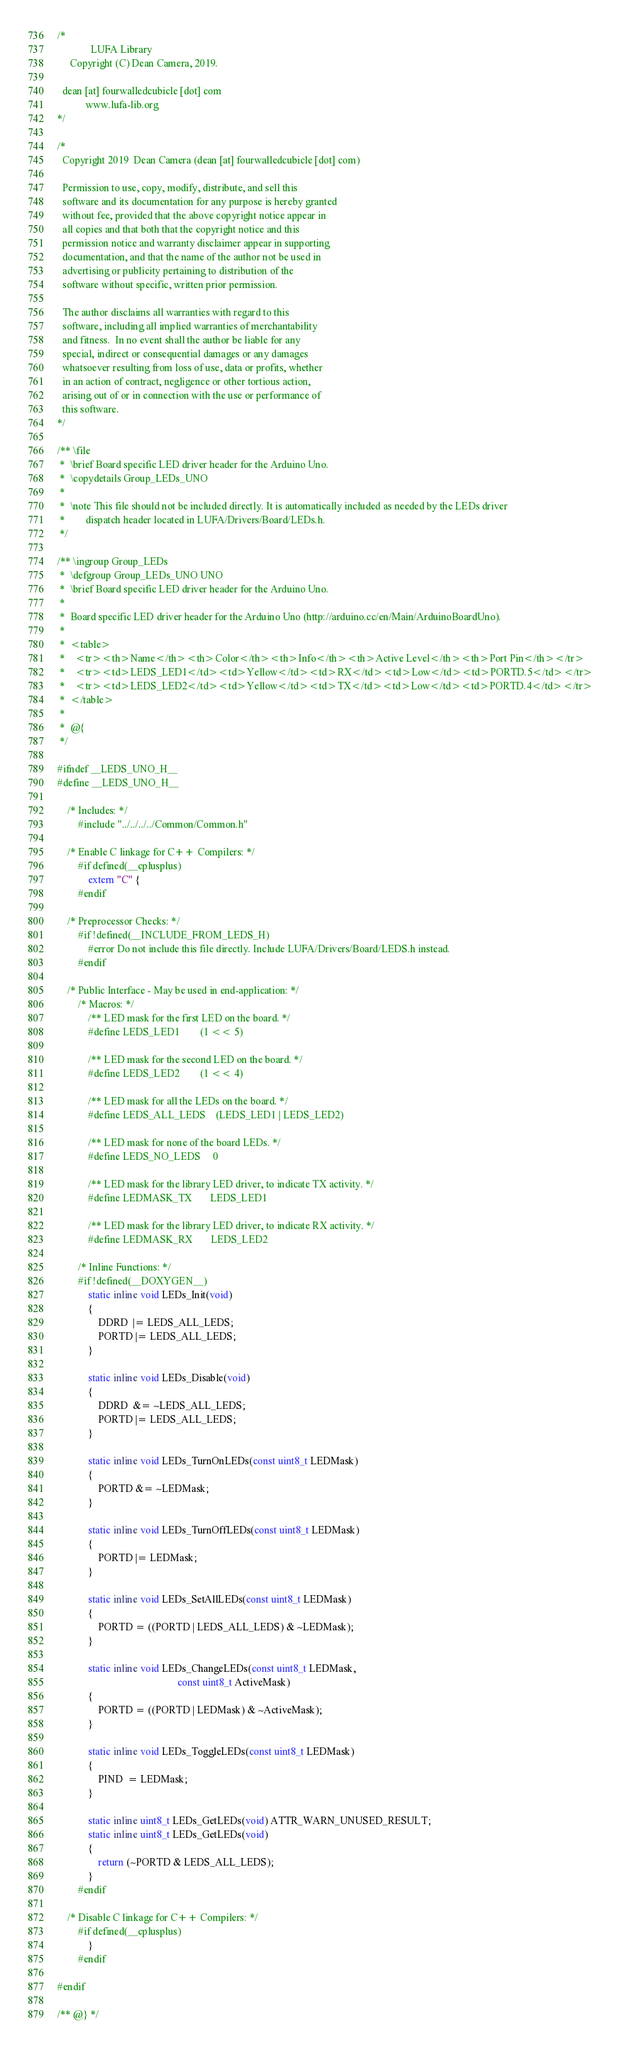Convert code to text. <code><loc_0><loc_0><loc_500><loc_500><_C_>/*
             LUFA Library
     Copyright (C) Dean Camera, 2019.

  dean [at] fourwalledcubicle [dot] com
           www.lufa-lib.org
*/

/*
  Copyright 2019  Dean Camera (dean [at] fourwalledcubicle [dot] com)

  Permission to use, copy, modify, distribute, and sell this
  software and its documentation for any purpose is hereby granted
  without fee, provided that the above copyright notice appear in
  all copies and that both that the copyright notice and this
  permission notice and warranty disclaimer appear in supporting
  documentation, and that the name of the author not be used in
  advertising or publicity pertaining to distribution of the
  software without specific, written prior permission.

  The author disclaims all warranties with regard to this
  software, including all implied warranties of merchantability
  and fitness.  In no event shall the author be liable for any
  special, indirect or consequential damages or any damages
  whatsoever resulting from loss of use, data or profits, whether
  in an action of contract, negligence or other tortious action,
  arising out of or in connection with the use or performance of
  this software.
*/

/** \file
 *  \brief Board specific LED driver header for the Arduino Uno.
 *  \copydetails Group_LEDs_UNO
 *
 *  \note This file should not be included directly. It is automatically included as needed by the LEDs driver
 *        dispatch header located in LUFA/Drivers/Board/LEDs.h.
 */

/** \ingroup Group_LEDs
 *  \defgroup Group_LEDs_UNO UNO
 *  \brief Board specific LED driver header for the Arduino Uno.
 *
 *  Board specific LED driver header for the Arduino Uno (http://arduino.cc/en/Main/ArduinoBoardUno).
 *
 *  <table>
 *    <tr><th>Name</th><th>Color</th><th>Info</th><th>Active Level</th><th>Port Pin</th></tr>
 *    <tr><td>LEDS_LED1</td><td>Yellow</td><td>RX</td><td>Low</td><td>PORTD.5</td></tr>
 *    <tr><td>LEDS_LED2</td><td>Yellow</td><td>TX</td><td>Low</td><td>PORTD.4</td></tr>
 *  </table>
 *
 *  @{
 */

#ifndef __LEDS_UNO_H__
#define __LEDS_UNO_H__

	/* Includes: */
		#include "../../../../Common/Common.h"

	/* Enable C linkage for C++ Compilers: */
		#if defined(__cplusplus)
			extern "C" {
		#endif

	/* Preprocessor Checks: */
		#if !defined(__INCLUDE_FROM_LEDS_H)
			#error Do not include this file directly. Include LUFA/Drivers/Board/LEDS.h instead.
		#endif

	/* Public Interface - May be used in end-application: */
		/* Macros: */
			/** LED mask for the first LED on the board. */
			#define LEDS_LED1        (1 << 5)

			/** LED mask for the second LED on the board. */
			#define LEDS_LED2        (1 << 4)

			/** LED mask for all the LEDs on the board. */
			#define LEDS_ALL_LEDS    (LEDS_LED1 | LEDS_LED2)

			/** LED mask for none of the board LEDs. */
			#define LEDS_NO_LEDS     0

			/** LED mask for the library LED driver, to indicate TX activity. */
			#define LEDMASK_TX       LEDS_LED1

			/** LED mask for the library LED driver, to indicate RX activity. */
			#define LEDMASK_RX       LEDS_LED2

		/* Inline Functions: */
		#if !defined(__DOXYGEN__)
			static inline void LEDs_Init(void)
			{
				DDRD  |= LEDS_ALL_LEDS;
				PORTD |= LEDS_ALL_LEDS;
			}

			static inline void LEDs_Disable(void)
			{
				DDRD  &= ~LEDS_ALL_LEDS;
				PORTD |= LEDS_ALL_LEDS;
			}

			static inline void LEDs_TurnOnLEDs(const uint8_t LEDMask)
			{
				PORTD &= ~LEDMask;
			}

			static inline void LEDs_TurnOffLEDs(const uint8_t LEDMask)
			{
				PORTD |= LEDMask;
			}

			static inline void LEDs_SetAllLEDs(const uint8_t LEDMask)
			{
				PORTD = ((PORTD | LEDS_ALL_LEDS) & ~LEDMask);
			}

			static inline void LEDs_ChangeLEDs(const uint8_t LEDMask,
			                                   const uint8_t ActiveMask)
			{
				PORTD = ((PORTD | LEDMask) & ~ActiveMask);
			}

			static inline void LEDs_ToggleLEDs(const uint8_t LEDMask)
			{
				PIND  = LEDMask;
			}

			static inline uint8_t LEDs_GetLEDs(void) ATTR_WARN_UNUSED_RESULT;
			static inline uint8_t LEDs_GetLEDs(void)
			{
				return (~PORTD & LEDS_ALL_LEDS);
			}
		#endif

	/* Disable C linkage for C++ Compilers: */
		#if defined(__cplusplus)
			}
		#endif

#endif

/** @} */

</code> 